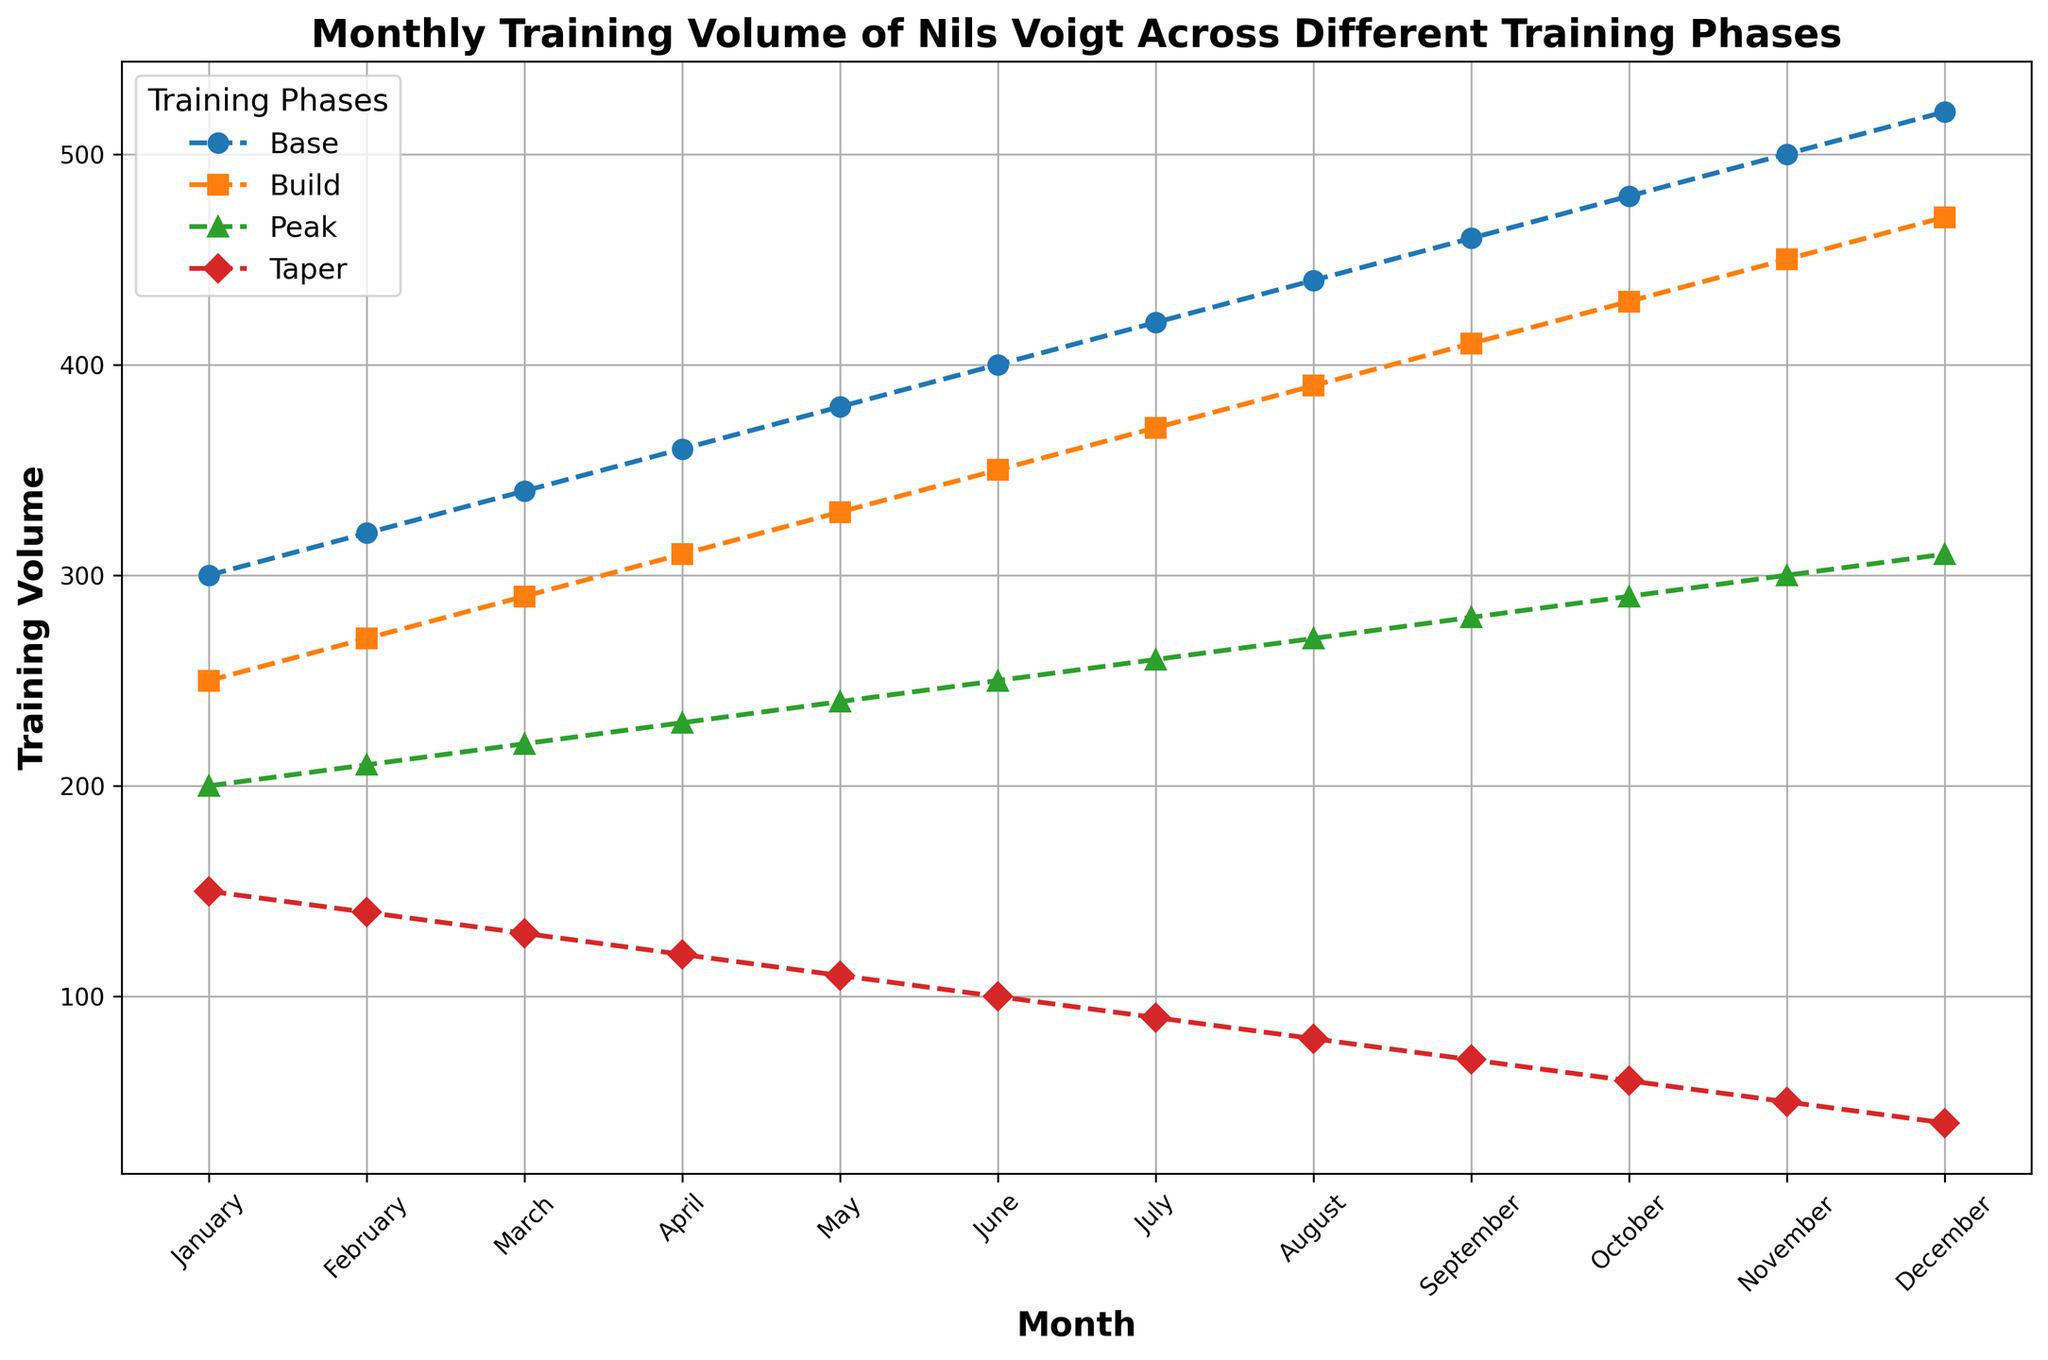What's the monthly training volume in the Base phase for April? Refer to the tick marks and data points on the line for the Base phase. Look for April and read off the value on the y-axis.
Answer: 360 During which month is the training volume for the Peak phase exactly 230? Locate the Peak phase line (green), find the point where it intersects the y-axis at 230, and move vertically downwards to identify the month.
Answer: April Which training phase has the highest volume in December? Follow the December marker on the x-axis upwards, then identify the phase with the highest point.
Answer: Base phase How does the training volume in February compare between the Build phase and Taper phase? Look at the data points for February on both the Build (orange) and Taper (red) lines, then compare their heights on the y-axis.
Answer: Build phase is higher What is the difference in training volume between the Base and Taper phases in July? Identify the volumes for the Base and Taper phases in July by looking at their respective data points, then subtract the Taper phase value from the Base phase value.
Answer: 420 - 90 = 330 Which month shows the smallest difference in training volume between the Peak and Taper phases? Calculate the difference between the Peak and Taper phases for each month by subtracting their values. Identify the month with the smallest result.
Answer: December (310 - 40 = 270) What is the average training volume for the Build phase in the first quarter (January to March)? Add up the training volumes for Build phase in January, February, and March, then divide by 3.
Answer: (250 + 270 + 290) / 3 = 270 Which phase shows the most gradual increase over the months? Compare the slopes of the lines representing each phase. The phase with the least steep slope has the most gradual increase.
Answer: Taper phase Is there any month where the training volume for the Base and Peak phases are equal? Compare the data points for Base and Peak phases across all months.
Answer: No In which month does the Taper phase training volume first drop below 100? Identify when the Taper phase line first crosses below the 100 mark on the y-axis.
Answer: June 